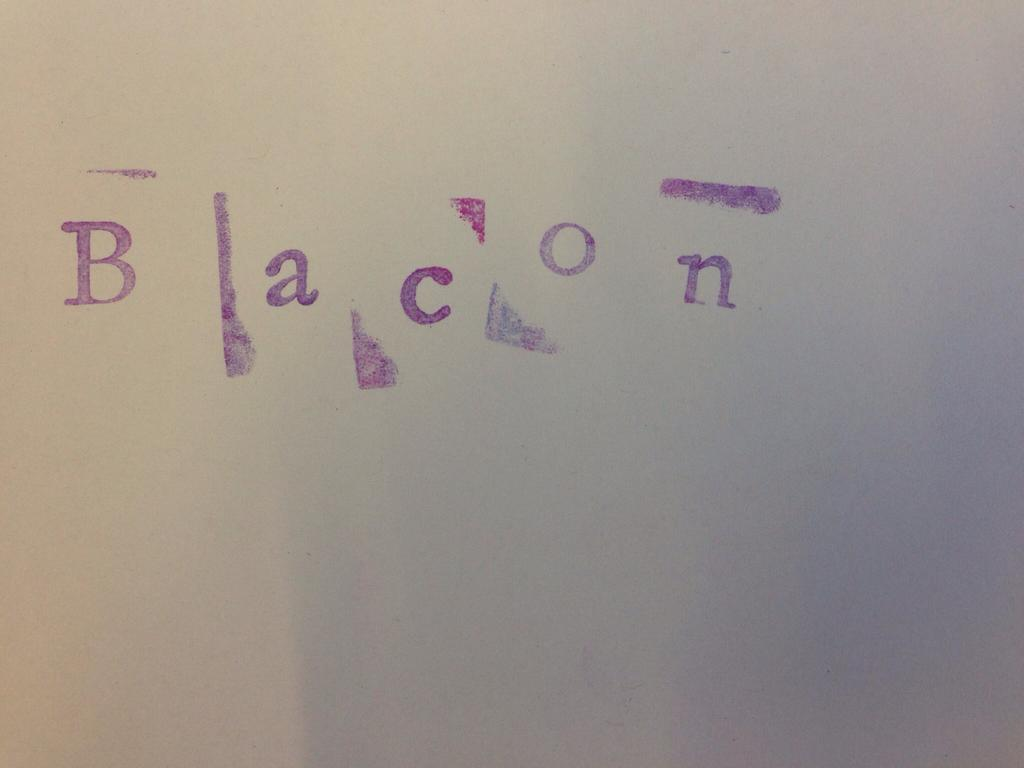Provide a one-sentence caption for the provided image. The word bacon is sloppily painted onto a sheet of paper. 